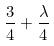Convert formula to latex. <formula><loc_0><loc_0><loc_500><loc_500>\frac { 3 } { 4 } + \frac { \lambda } { 4 }</formula> 